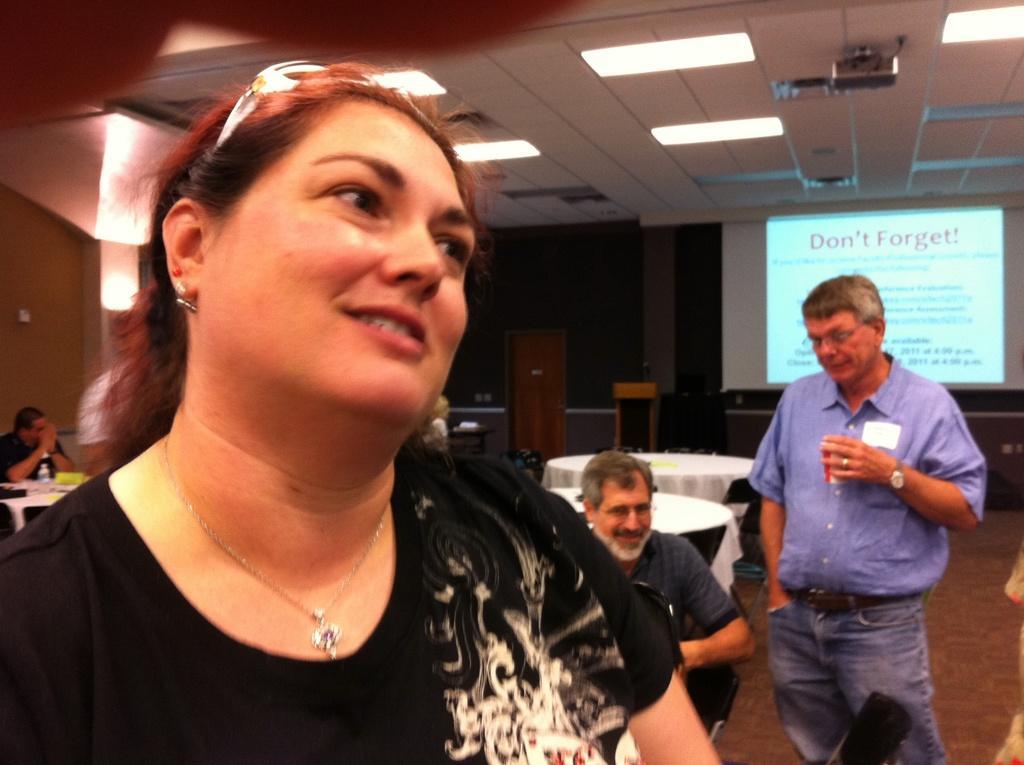Could you give a brief overview of what you see in this image? In this picture I see a woman in front and I see that she is standing and behind her I see 2 men in which the man on the left is sitting on chairs and the man on the right is holding a cup in his hand and I see number of tables and in the background I see a projector screen on which there is something written and on the ceiling I see the lights and on the left side of this image I see a person who is sitting. 